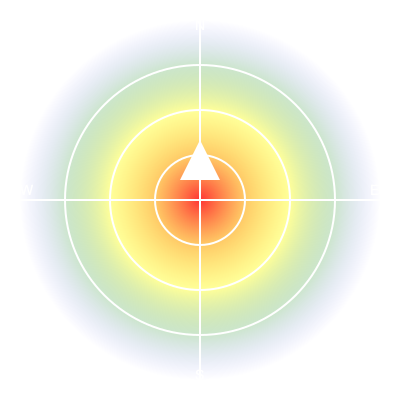Based on the weather radar map shown, which direction should you anticipate the storm moving, and how might this affect your golf game planning for the next few hours? 1. Analyze the radar image:
   - The radar shows a circular pattern with colors ranging from red (center) to blue (outer edge).
   - Red indicates the most intense precipitation, while blue represents lighter precipitation.
   - The gradient suggests the storm's intensity decreases as it moves outward.

2. Identify storm movement:
   - The white triangle in the north section points south, indicating the storm's direction.
   - Weather systems in the Northern Hemisphere typically move from west to east.

3. Interpret storm movement:
   - The storm is likely moving from northwest to southeast.

4. Calculate timeframe:
   - Assuming each radar ring represents about 20 km and an average storm speed of 30 km/h:
   - Time to reach the center: $\frac{45 \text{ km}}{30 \text{ km/h}} = 1.5 \text{ hours}$

5. Golf game impact:
   - The storm will likely affect the golf course in about 1.5 hours.
   - Expect deteriorating conditions: increased wind, potential rain, and possibly lightning.

6. Planning considerations:
   - Aim to complete your round within 1.5 hours if possible.
   - Be prepared to seek shelter if the storm arrives earlier or intensifies.
   - Monitor local weather alerts for any changes in the storm's trajectory or severity.
Answer: Southeast; plan to finish within 1.5 hours or prepare for potential weather delays. 